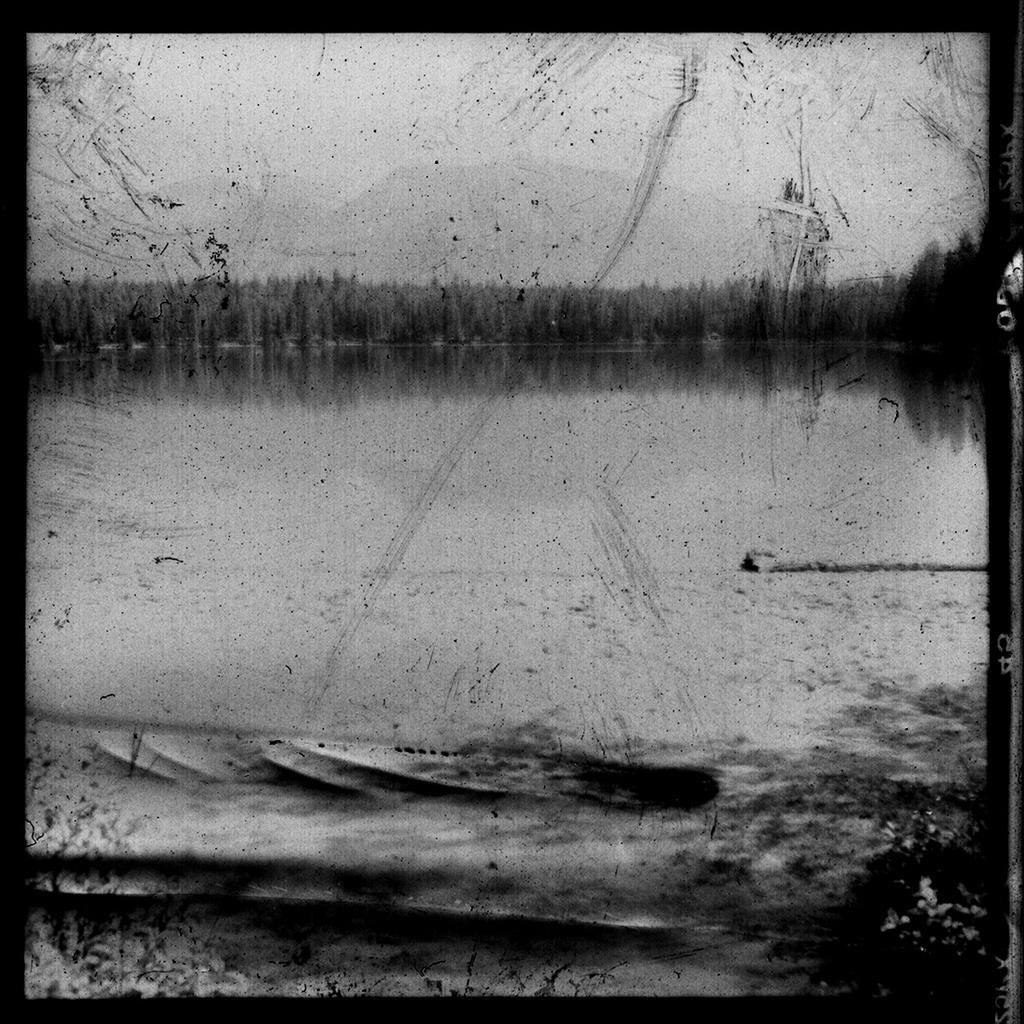What is the color scheme of the image? The image is black and white. What natural feature can be seen in the image? There is a lake in the image. What type of vegetation is visible in the background of the image? There are trees visible in the background of the image. What design element is present around the image? The image has black borders. What is the name of the jar that is visible in the image? There is no jar present in the image. How many ants can be seen crawling on the trees in the image? There are no ants visible in the image; only trees are mentioned in the background. 